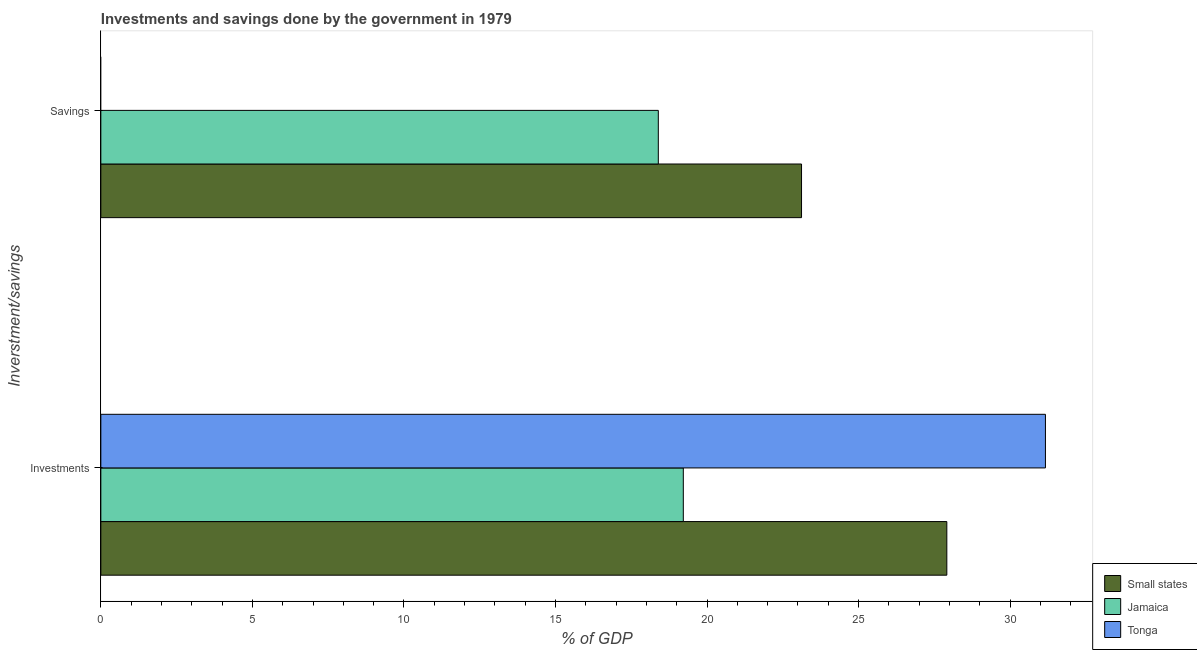How many groups of bars are there?
Give a very brief answer. 2. Are the number of bars on each tick of the Y-axis equal?
Provide a succinct answer. No. How many bars are there on the 1st tick from the top?
Your response must be concise. 2. What is the label of the 1st group of bars from the top?
Make the answer very short. Savings. What is the investments of government in Small states?
Offer a terse response. 27.91. Across all countries, what is the maximum savings of government?
Give a very brief answer. 23.12. In which country was the savings of government maximum?
Provide a succinct answer. Small states. What is the total savings of government in the graph?
Provide a short and direct response. 41.51. What is the difference between the investments of government in Small states and that in Tonga?
Ensure brevity in your answer.  -3.25. What is the difference between the savings of government in Jamaica and the investments of government in Small states?
Ensure brevity in your answer.  -9.52. What is the average investments of government per country?
Offer a terse response. 26.1. What is the difference between the investments of government and savings of government in Small states?
Your answer should be compact. 4.79. In how many countries, is the savings of government greater than 12 %?
Make the answer very short. 2. What is the ratio of the savings of government in Jamaica to that in Small states?
Make the answer very short. 0.8. Is the savings of government in Jamaica less than that in Small states?
Offer a terse response. Yes. Are all the bars in the graph horizontal?
Your answer should be compact. Yes. How many countries are there in the graph?
Your response must be concise. 3. What is the difference between two consecutive major ticks on the X-axis?
Your answer should be very brief. 5. Are the values on the major ticks of X-axis written in scientific E-notation?
Give a very brief answer. No. Does the graph contain grids?
Make the answer very short. No. How are the legend labels stacked?
Offer a very short reply. Vertical. What is the title of the graph?
Make the answer very short. Investments and savings done by the government in 1979. What is the label or title of the X-axis?
Your response must be concise. % of GDP. What is the label or title of the Y-axis?
Your answer should be very brief. Inverstment/savings. What is the % of GDP in Small states in Investments?
Provide a succinct answer. 27.91. What is the % of GDP of Jamaica in Investments?
Your response must be concise. 19.22. What is the % of GDP in Tonga in Investments?
Keep it short and to the point. 31.17. What is the % of GDP in Small states in Savings?
Provide a short and direct response. 23.12. What is the % of GDP in Jamaica in Savings?
Offer a terse response. 18.39. Across all Inverstment/savings, what is the maximum % of GDP in Small states?
Provide a succinct answer. 27.91. Across all Inverstment/savings, what is the maximum % of GDP in Jamaica?
Offer a terse response. 19.22. Across all Inverstment/savings, what is the maximum % of GDP of Tonga?
Keep it short and to the point. 31.17. Across all Inverstment/savings, what is the minimum % of GDP in Small states?
Your response must be concise. 23.12. Across all Inverstment/savings, what is the minimum % of GDP in Jamaica?
Give a very brief answer. 18.39. What is the total % of GDP in Small states in the graph?
Your response must be concise. 51.03. What is the total % of GDP in Jamaica in the graph?
Give a very brief answer. 37.61. What is the total % of GDP in Tonga in the graph?
Offer a very short reply. 31.17. What is the difference between the % of GDP in Small states in Investments and that in Savings?
Provide a short and direct response. 4.79. What is the difference between the % of GDP of Jamaica in Investments and that in Savings?
Make the answer very short. 0.82. What is the difference between the % of GDP in Small states in Investments and the % of GDP in Jamaica in Savings?
Make the answer very short. 9.52. What is the average % of GDP in Small states per Inverstment/savings?
Ensure brevity in your answer.  25.52. What is the average % of GDP in Jamaica per Inverstment/savings?
Keep it short and to the point. 18.81. What is the average % of GDP of Tonga per Inverstment/savings?
Make the answer very short. 15.58. What is the difference between the % of GDP in Small states and % of GDP in Jamaica in Investments?
Offer a very short reply. 8.69. What is the difference between the % of GDP in Small states and % of GDP in Tonga in Investments?
Your answer should be very brief. -3.25. What is the difference between the % of GDP of Jamaica and % of GDP of Tonga in Investments?
Keep it short and to the point. -11.95. What is the difference between the % of GDP in Small states and % of GDP in Jamaica in Savings?
Offer a terse response. 4.73. What is the ratio of the % of GDP of Small states in Investments to that in Savings?
Give a very brief answer. 1.21. What is the ratio of the % of GDP of Jamaica in Investments to that in Savings?
Provide a succinct answer. 1.04. What is the difference between the highest and the second highest % of GDP in Small states?
Make the answer very short. 4.79. What is the difference between the highest and the second highest % of GDP in Jamaica?
Offer a terse response. 0.82. What is the difference between the highest and the lowest % of GDP of Small states?
Offer a terse response. 4.79. What is the difference between the highest and the lowest % of GDP of Jamaica?
Offer a terse response. 0.82. What is the difference between the highest and the lowest % of GDP of Tonga?
Provide a short and direct response. 31.17. 